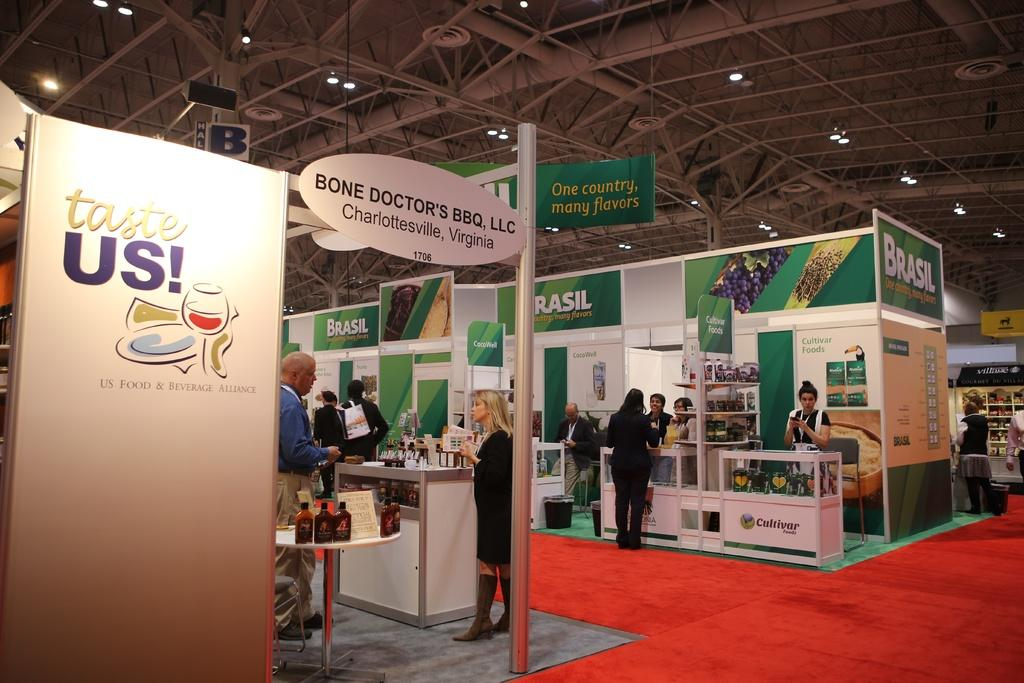<image>
Render a clear and concise summary of the photo. A large white billboard with the phase "Taste Us" in an open auditorium with red carpet. 